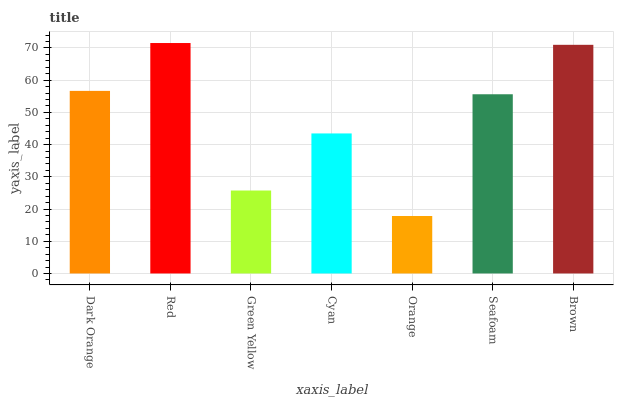Is Orange the minimum?
Answer yes or no. Yes. Is Red the maximum?
Answer yes or no. Yes. Is Green Yellow the minimum?
Answer yes or no. No. Is Green Yellow the maximum?
Answer yes or no. No. Is Red greater than Green Yellow?
Answer yes or no. Yes. Is Green Yellow less than Red?
Answer yes or no. Yes. Is Green Yellow greater than Red?
Answer yes or no. No. Is Red less than Green Yellow?
Answer yes or no. No. Is Seafoam the high median?
Answer yes or no. Yes. Is Seafoam the low median?
Answer yes or no. Yes. Is Brown the high median?
Answer yes or no. No. Is Dark Orange the low median?
Answer yes or no. No. 